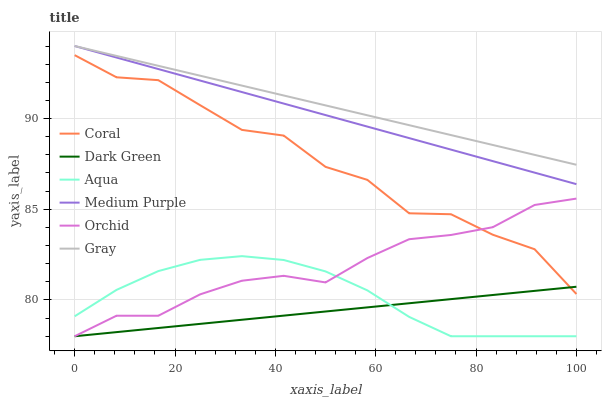Does Dark Green have the minimum area under the curve?
Answer yes or no. Yes. Does Gray have the maximum area under the curve?
Answer yes or no. Yes. Does Coral have the minimum area under the curve?
Answer yes or no. No. Does Coral have the maximum area under the curve?
Answer yes or no. No. Is Gray the smoothest?
Answer yes or no. Yes. Is Coral the roughest?
Answer yes or no. Yes. Is Aqua the smoothest?
Answer yes or no. No. Is Aqua the roughest?
Answer yes or no. No. Does Aqua have the lowest value?
Answer yes or no. Yes. Does Coral have the lowest value?
Answer yes or no. No. Does Medium Purple have the highest value?
Answer yes or no. Yes. Does Coral have the highest value?
Answer yes or no. No. Is Aqua less than Medium Purple?
Answer yes or no. Yes. Is Medium Purple greater than Coral?
Answer yes or no. Yes. Does Coral intersect Dark Green?
Answer yes or no. Yes. Is Coral less than Dark Green?
Answer yes or no. No. Is Coral greater than Dark Green?
Answer yes or no. No. Does Aqua intersect Medium Purple?
Answer yes or no. No. 